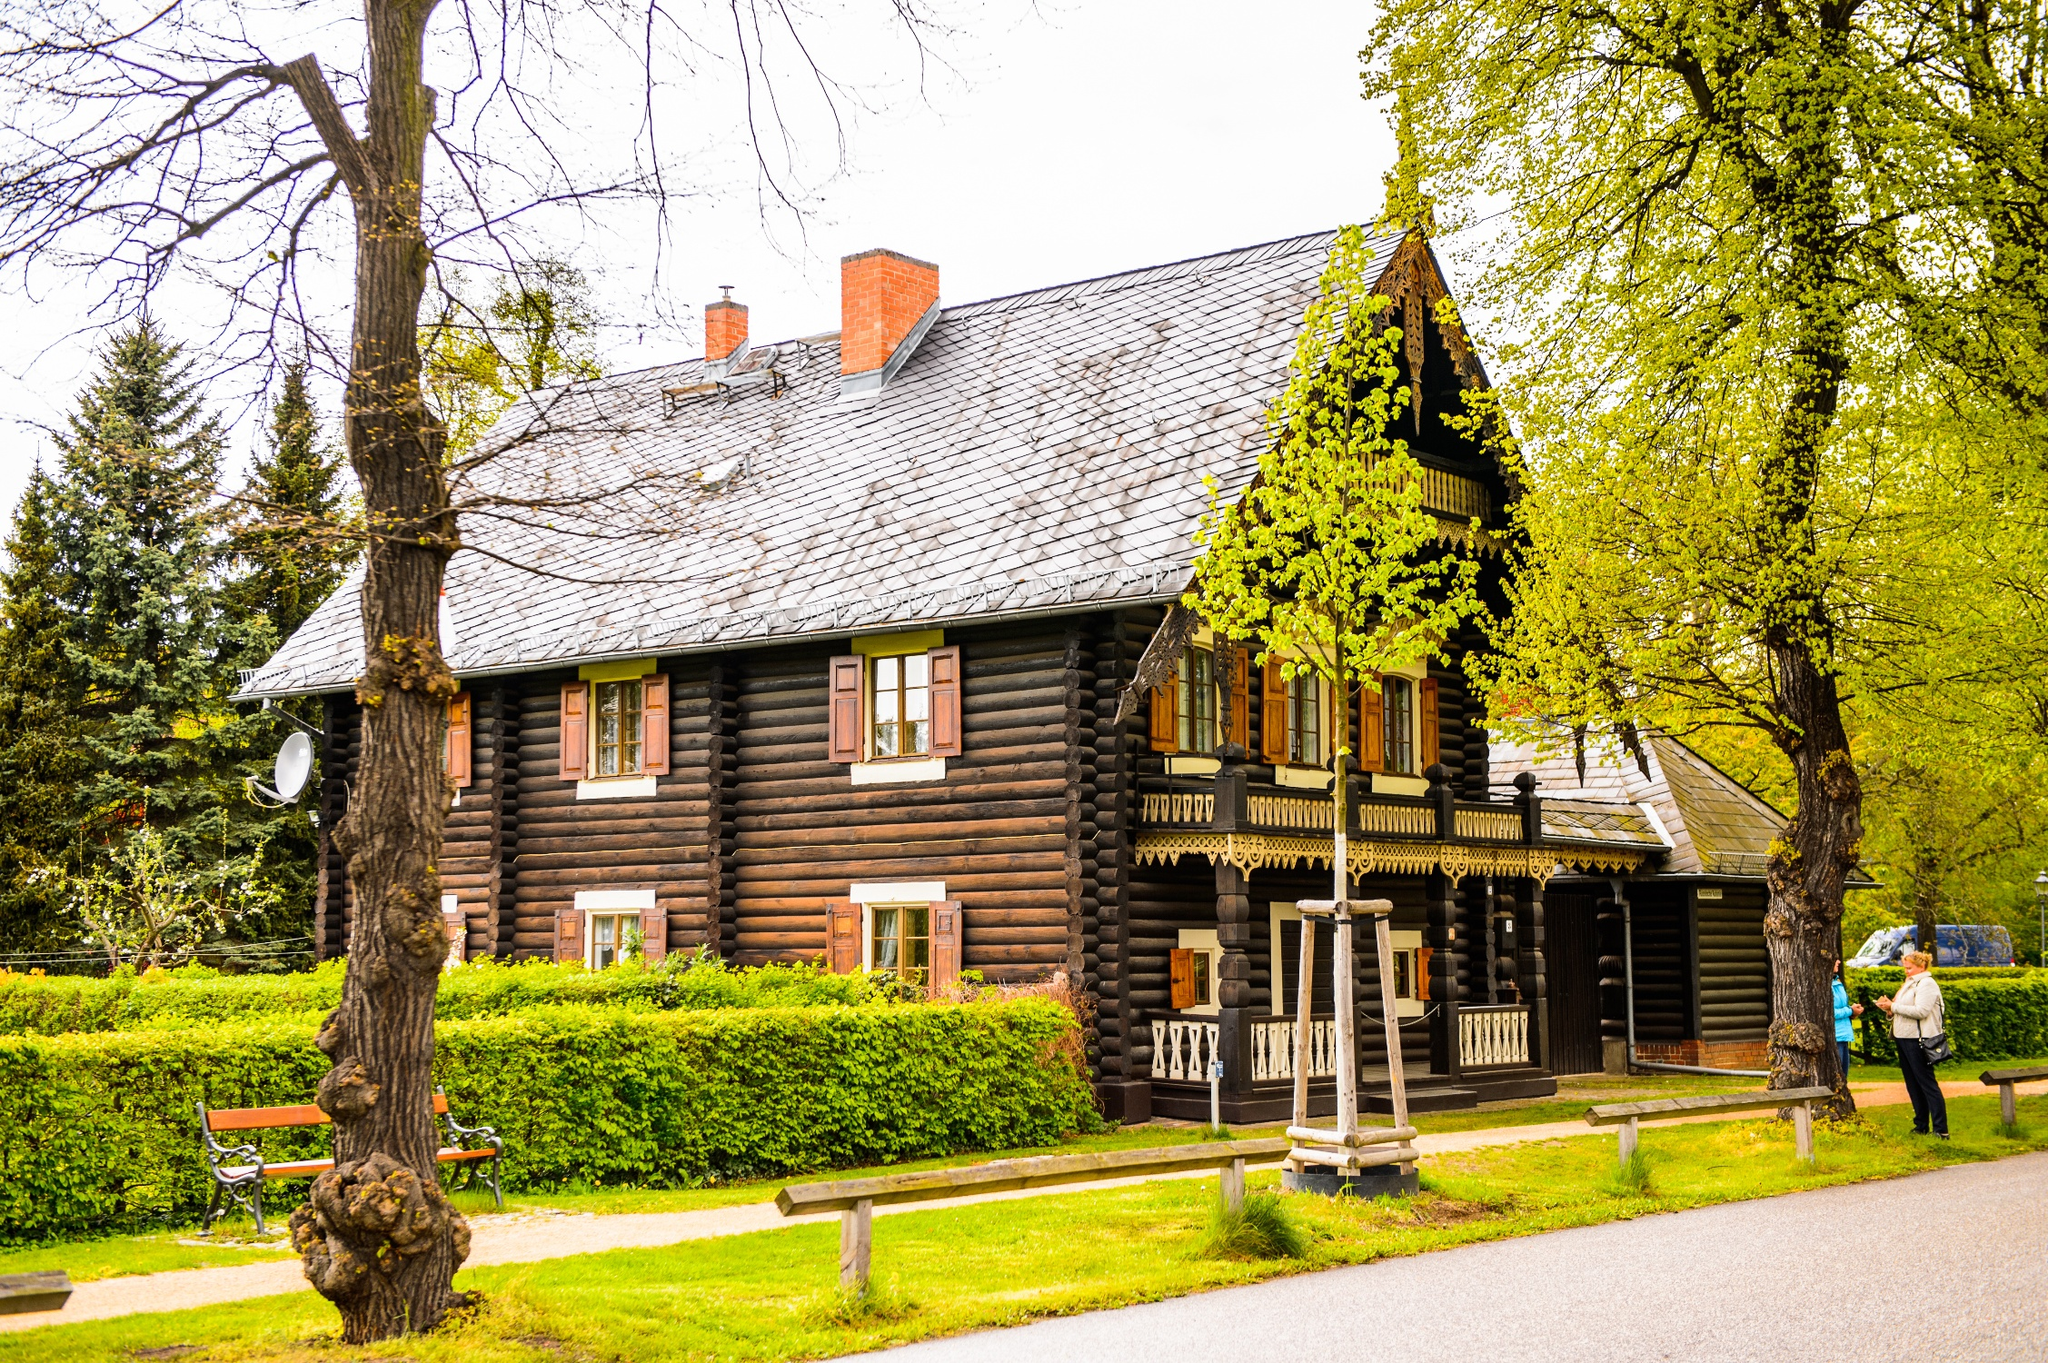Considering the house's features, how could the interior be organized and decorated? The interior of the house is likely to exude a cozy, rustic charm consistent with its exterior. Considering the visible chimney, a central fireplace might be the heart of the home, serving as a warm gathering spot. The use of natural wood extends inside, with possible exposed log walls and wooden flooring. Traditional furnishings, such as quilted throws, wooden furniture, and perhaps wrought iron accents, would complement the historical vibe. Decor might include practical and vintage items, like ceramic pots, lanterns, and woven rugs, to enhance the cabin's old-world, homely feel. The layout is likely straightforward, with a main living area, a kitchen, and several small bedrooms under the steeply pitched roof, optimized for family or small group stays. 